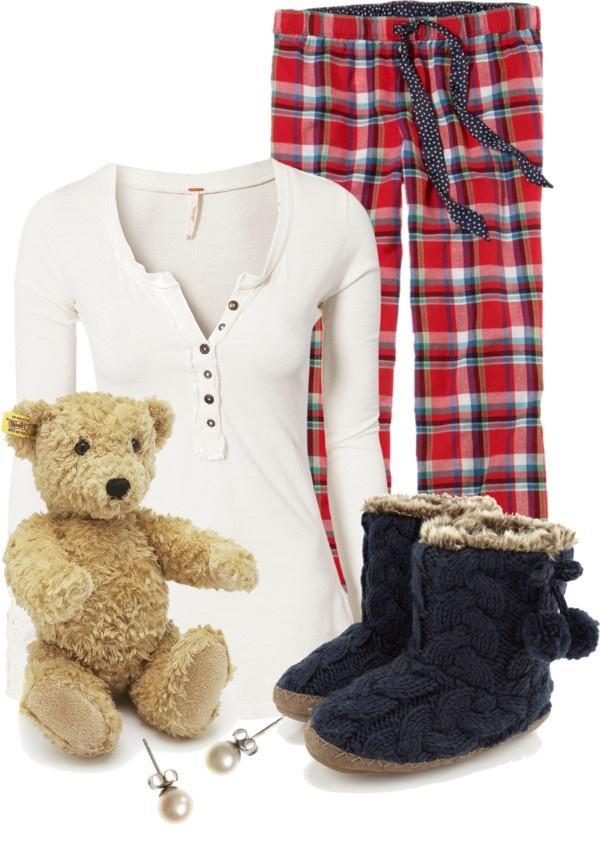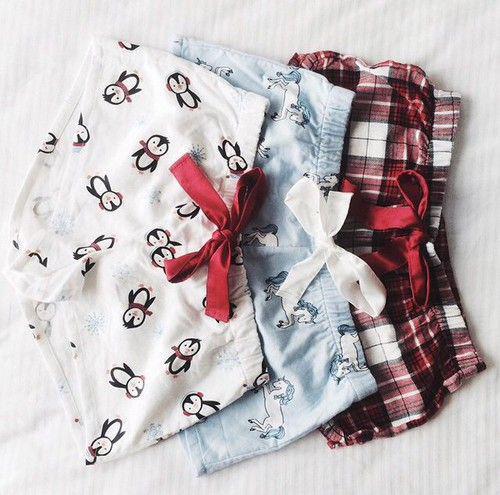The first image is the image on the left, the second image is the image on the right. Considering the images on both sides, is "The right image contains at least one person dressed in sleep attire." valid? Answer yes or no. No. The first image is the image on the left, the second image is the image on the right. Analyze the images presented: Is the assertion "At least one pair of pajamas in both images feature a plaid bottom." valid? Answer yes or no. Yes. 